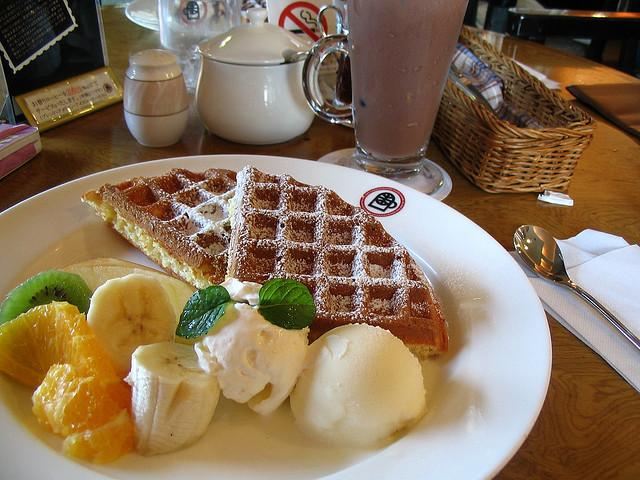What fruit can be seen?
Answer briefly. Bananas. What are they drinking?
Quick response, please. Smoothie. Is there a knife in the photo?
Give a very brief answer. No. What mealtime is this?
Give a very brief answer. Breakfast. What kind of fruit are on the dish?
Answer briefly. Banana. 